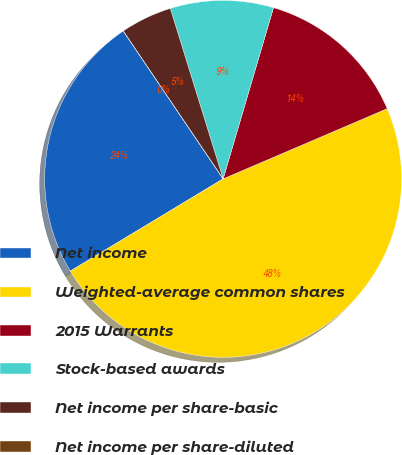Convert chart to OTSL. <chart><loc_0><loc_0><loc_500><loc_500><pie_chart><fcel>Net income<fcel>Weighted-average common shares<fcel>2015 Warrants<fcel>Stock-based awards<fcel>Net income per share-basic<fcel>Net income per share-diluted<nl><fcel>24.19%<fcel>47.8%<fcel>14.01%<fcel>9.34%<fcel>4.67%<fcel>0.0%<nl></chart> 